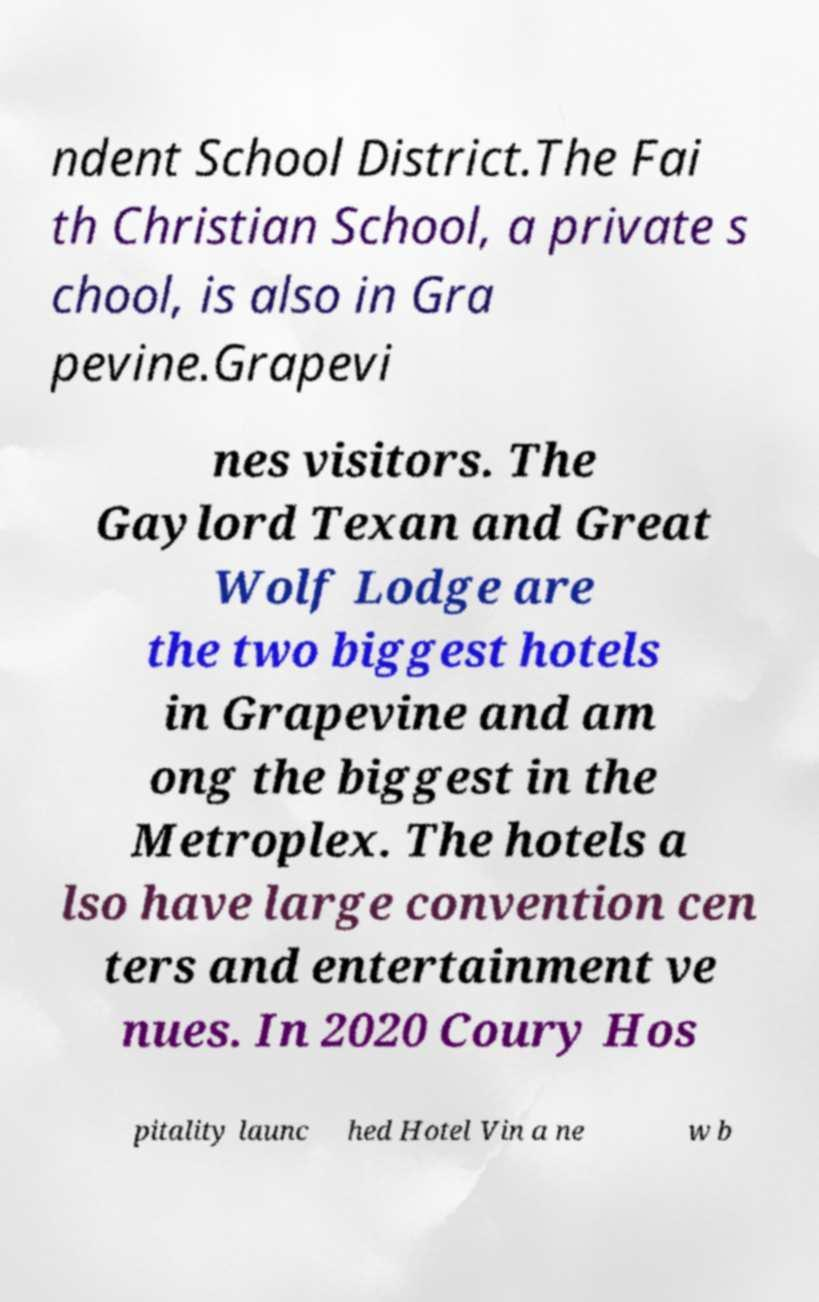There's text embedded in this image that I need extracted. Can you transcribe it verbatim? ndent School District.The Fai th Christian School, a private s chool, is also in Gra pevine.Grapevi nes visitors. The Gaylord Texan and Great Wolf Lodge are the two biggest hotels in Grapevine and am ong the biggest in the Metroplex. The hotels a lso have large convention cen ters and entertainment ve nues. In 2020 Coury Hos pitality launc hed Hotel Vin a ne w b 